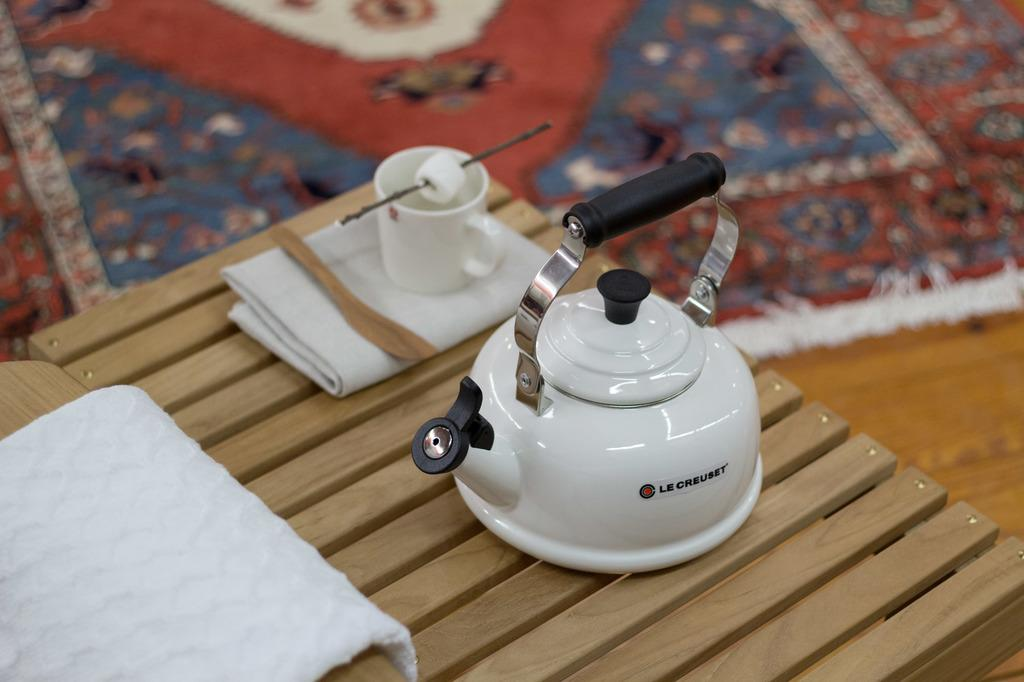What piece of furniture is in the image? There is a table in the image. What is on top of the table? A kettle, clothes, a spoon, and a cup are visible on the table. Can you describe the unspecified object on the table? Unfortunately, the facts provided do not give any details about the unspecified object on the table. What is the background of the image? There is a floor mat in the background of the image. What type of steel is used to make the wave in the image? There is no wave or steel present in the image. How does the oil affect the appearance of the objects on the table in the image? There is no oil present in the image, so it does not affect the appearance of the objects on the table. 